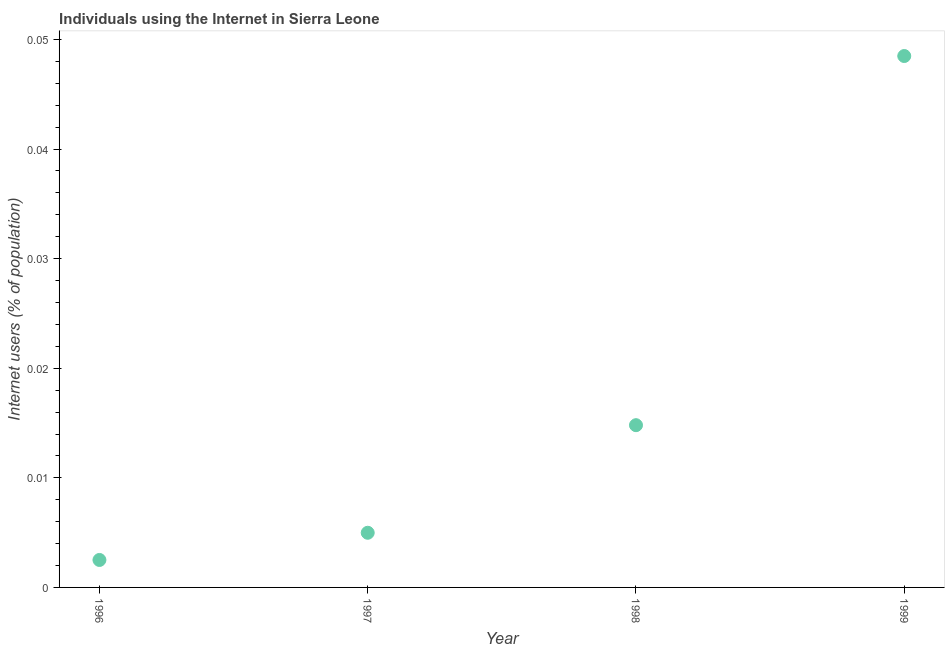What is the number of internet users in 1998?
Provide a succinct answer. 0.01. Across all years, what is the maximum number of internet users?
Ensure brevity in your answer.  0.05. Across all years, what is the minimum number of internet users?
Provide a succinct answer. 0. In which year was the number of internet users maximum?
Make the answer very short. 1999. What is the sum of the number of internet users?
Provide a short and direct response. 0.07. What is the difference between the number of internet users in 1997 and 1999?
Your answer should be very brief. -0.04. What is the average number of internet users per year?
Ensure brevity in your answer.  0.02. What is the median number of internet users?
Ensure brevity in your answer.  0.01. In how many years, is the number of internet users greater than 0.028 %?
Your answer should be compact. 1. What is the ratio of the number of internet users in 1997 to that in 1998?
Make the answer very short. 0.34. Is the number of internet users in 1998 less than that in 1999?
Give a very brief answer. Yes. What is the difference between the highest and the second highest number of internet users?
Your response must be concise. 0.03. What is the difference between the highest and the lowest number of internet users?
Your answer should be compact. 0.05. In how many years, is the number of internet users greater than the average number of internet users taken over all years?
Provide a succinct answer. 1. How many years are there in the graph?
Your response must be concise. 4. Does the graph contain any zero values?
Ensure brevity in your answer.  No. What is the title of the graph?
Ensure brevity in your answer.  Individuals using the Internet in Sierra Leone. What is the label or title of the X-axis?
Provide a short and direct response. Year. What is the label or title of the Y-axis?
Make the answer very short. Internet users (% of population). What is the Internet users (% of population) in 1996?
Give a very brief answer. 0. What is the Internet users (% of population) in 1997?
Provide a succinct answer. 0. What is the Internet users (% of population) in 1998?
Ensure brevity in your answer.  0.01. What is the Internet users (% of population) in 1999?
Ensure brevity in your answer.  0.05. What is the difference between the Internet users (% of population) in 1996 and 1997?
Provide a succinct answer. -0. What is the difference between the Internet users (% of population) in 1996 and 1998?
Make the answer very short. -0.01. What is the difference between the Internet users (% of population) in 1996 and 1999?
Ensure brevity in your answer.  -0.05. What is the difference between the Internet users (% of population) in 1997 and 1998?
Keep it short and to the point. -0.01. What is the difference between the Internet users (% of population) in 1997 and 1999?
Your answer should be very brief. -0.04. What is the difference between the Internet users (% of population) in 1998 and 1999?
Ensure brevity in your answer.  -0.03. What is the ratio of the Internet users (% of population) in 1996 to that in 1997?
Make the answer very short. 0.5. What is the ratio of the Internet users (% of population) in 1996 to that in 1998?
Ensure brevity in your answer.  0.17. What is the ratio of the Internet users (% of population) in 1996 to that in 1999?
Keep it short and to the point. 0.05. What is the ratio of the Internet users (% of population) in 1997 to that in 1998?
Offer a very short reply. 0.34. What is the ratio of the Internet users (% of population) in 1997 to that in 1999?
Keep it short and to the point. 0.1. What is the ratio of the Internet users (% of population) in 1998 to that in 1999?
Provide a succinct answer. 0.3. 